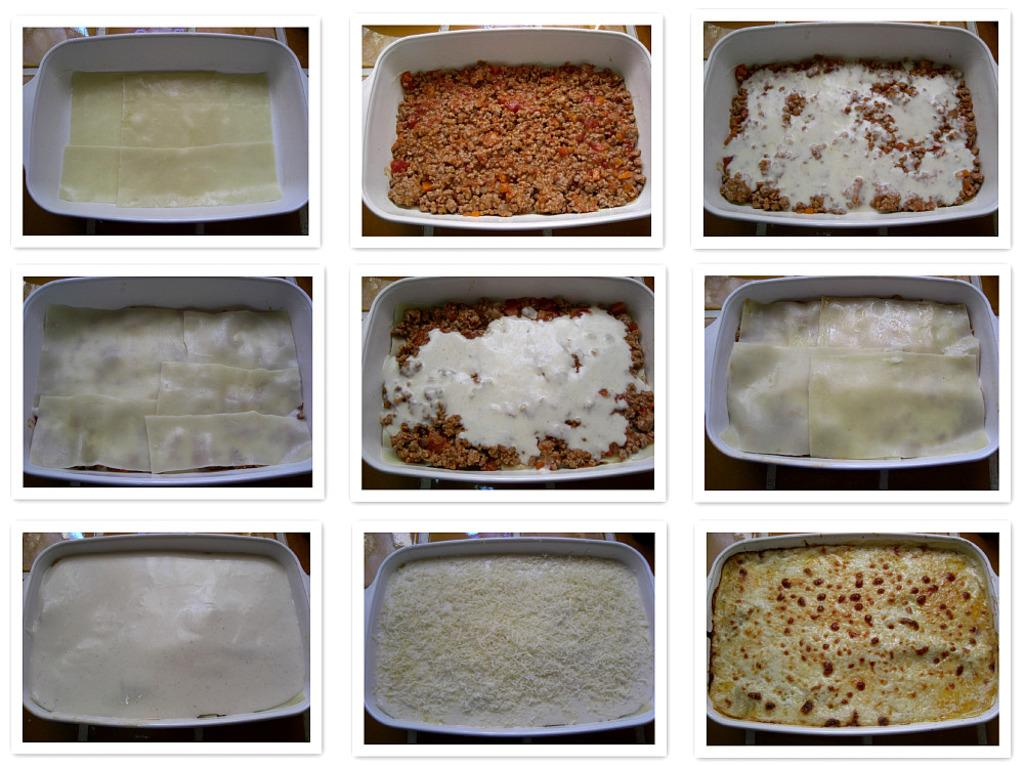What type of images are present in the collage? The collage contains food images. Can you describe the arrangement of the images in the collage? The arrangement of the images in the collage cannot be determined from the provided fact. What types of food can be seen in the collage? The specific types of food in the collage cannot be determined from the provided fact. What type of seed is visible in the image? There is no seed present in the image; it contains a collage of food images. 